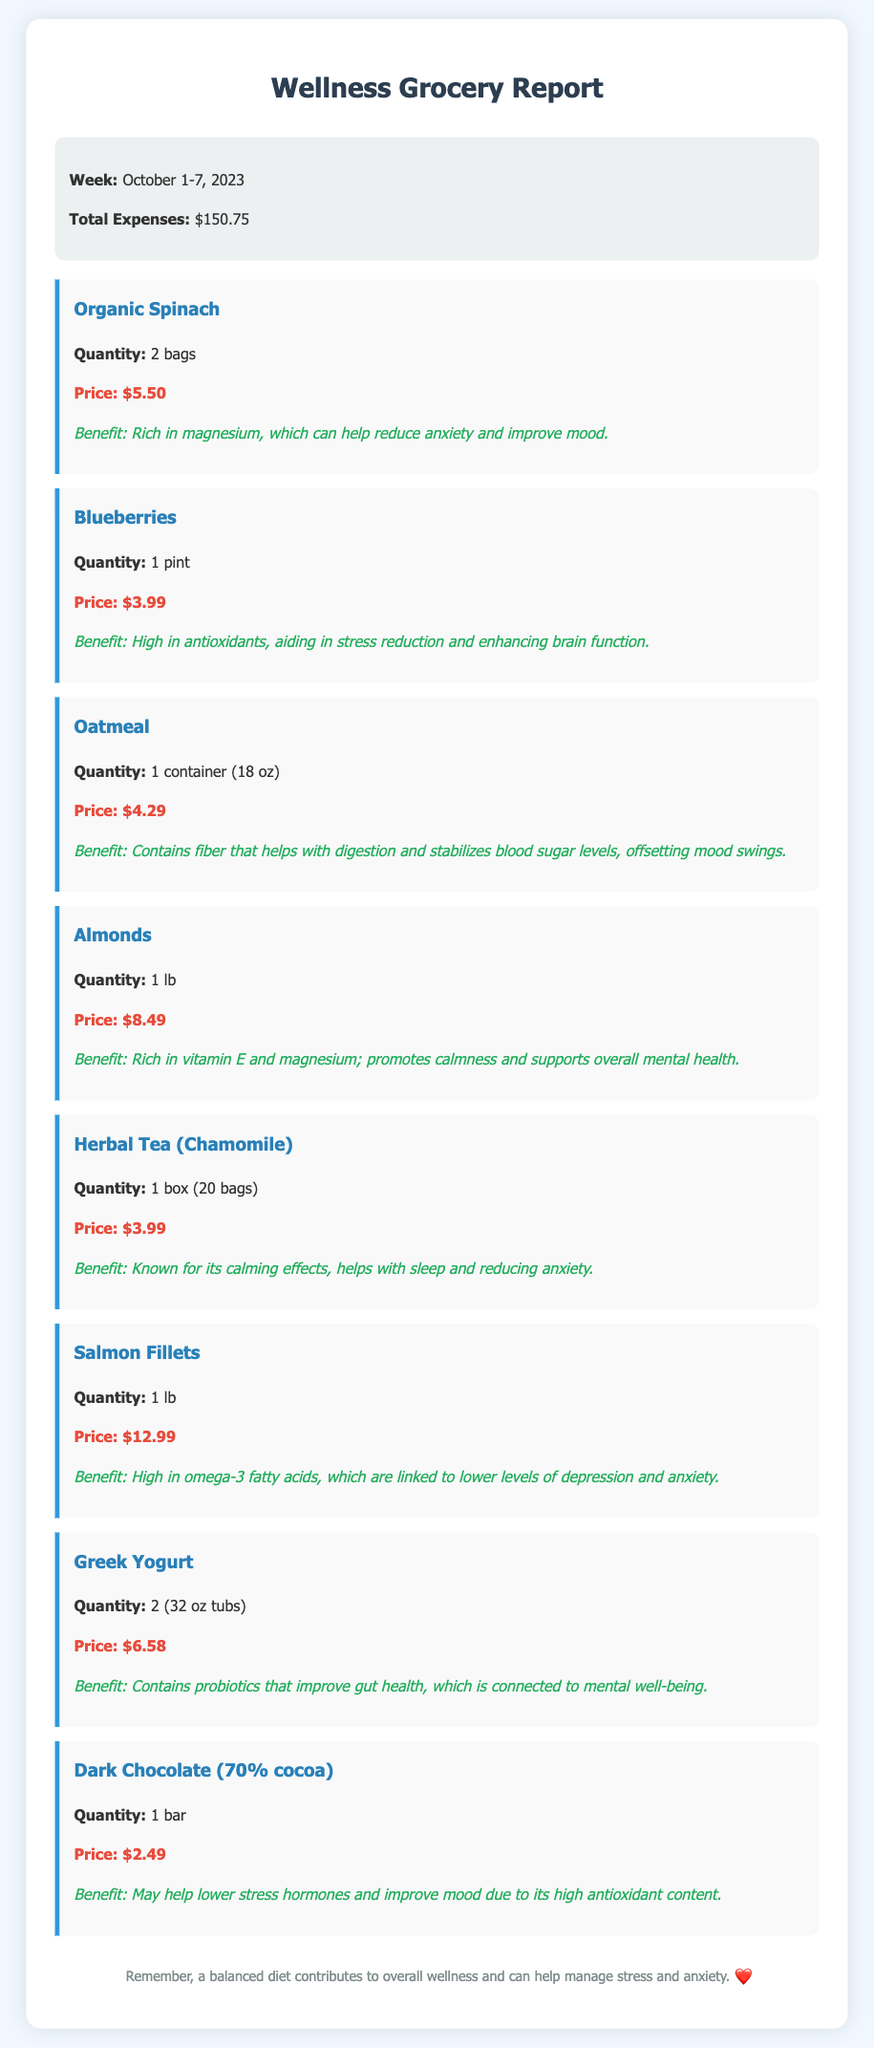What is the total expense for the week? The total expense is stated directly in the summary section of the document.
Answer: $150.75 How many bags of Organic Spinach were purchased? The quantity of Organic Spinach is specified in its item description.
Answer: 2 bags What benefit does Blueberries offer? The benefit of Blueberries is listed in the item description, highlighting its health properties.
Answer: High in antioxidants, aiding in stress reduction and enhancing brain function Which item is known for calming effects? The item known for its calming effects is indicated in the benefit section of the Herbal Tea.
Answer: Herbal Tea (Chamomile) How much did the Salmon Fillets cost? The price of Salmon Fillets is provided next to the item name in the document.
Answer: $12.99 What is the quantity of Greek Yogurt purchased? The item description specifies the quantity purchased of Greek Yogurt.
Answer: 2 (32 oz tubs) Which item is rich in magnesium and supports mental health? The benefit section of Almonds highlights its rich magnesium content and its mental health benefits.
Answer: Almonds How many items are listed in the document? The total number of items can be counted by reviewing the items section in the document.
Answer: 8 items 